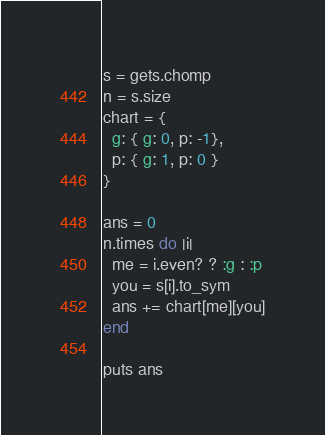Convert code to text. <code><loc_0><loc_0><loc_500><loc_500><_Ruby_>s = gets.chomp
n = s.size
chart = {
  g: { g: 0, p: -1},
  p: { g: 1, p: 0 } 
}

ans = 0
n.times do |i|
  me = i.even? ? :g : :p
  you = s[i].to_sym
  ans += chart[me][you]
end

puts ans</code> 